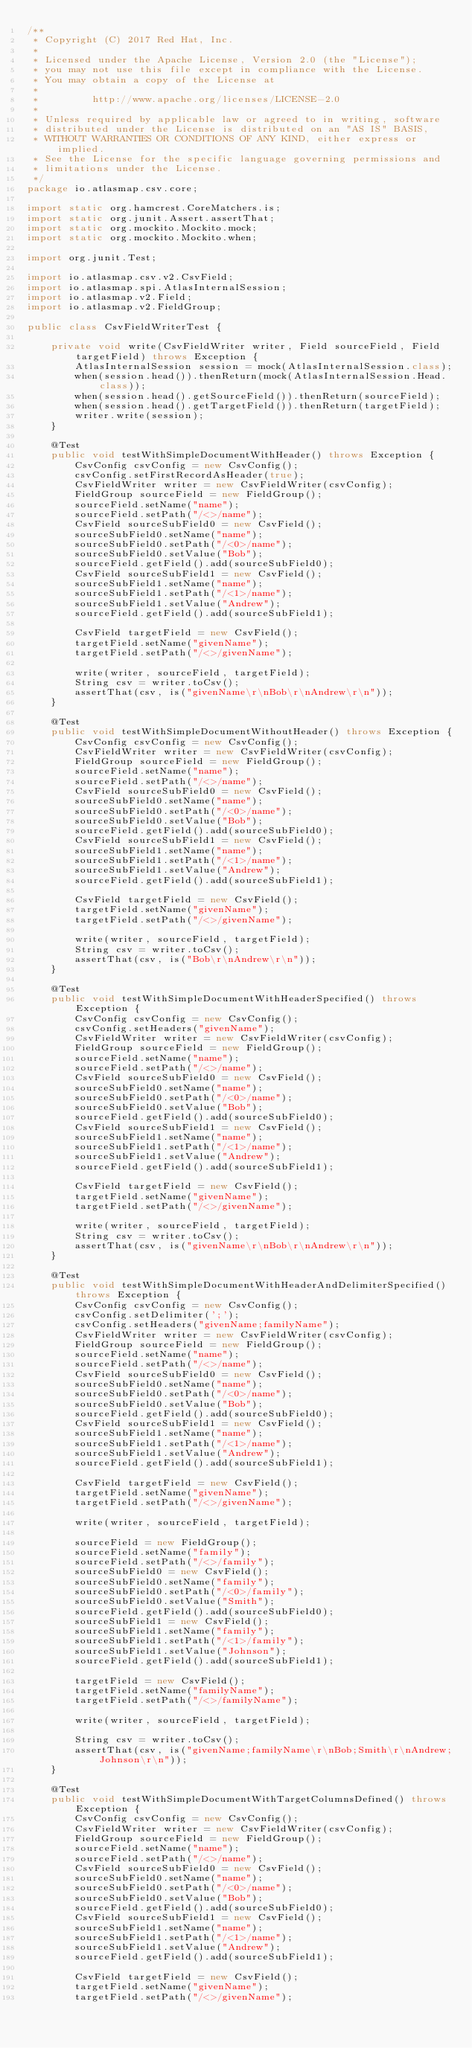Convert code to text. <code><loc_0><loc_0><loc_500><loc_500><_Java_>/**
 * Copyright (C) 2017 Red Hat, Inc.
 *
 * Licensed under the Apache License, Version 2.0 (the "License");
 * you may not use this file except in compliance with the License.
 * You may obtain a copy of the License at
 *
 *         http://www.apache.org/licenses/LICENSE-2.0
 *
 * Unless required by applicable law or agreed to in writing, software
 * distributed under the License is distributed on an "AS IS" BASIS,
 * WITHOUT WARRANTIES OR CONDITIONS OF ANY KIND, either express or implied.
 * See the License for the specific language governing permissions and
 * limitations under the License.
 */
package io.atlasmap.csv.core;

import static org.hamcrest.CoreMatchers.is;
import static org.junit.Assert.assertThat;
import static org.mockito.Mockito.mock;
import static org.mockito.Mockito.when;

import org.junit.Test;

import io.atlasmap.csv.v2.CsvField;
import io.atlasmap.spi.AtlasInternalSession;
import io.atlasmap.v2.Field;
import io.atlasmap.v2.FieldGroup;

public class CsvFieldWriterTest {

    private void write(CsvFieldWriter writer, Field sourceField, Field targetField) throws Exception {
        AtlasInternalSession session = mock(AtlasInternalSession.class);
        when(session.head()).thenReturn(mock(AtlasInternalSession.Head.class));
        when(session.head().getSourceField()).thenReturn(sourceField);
        when(session.head().getTargetField()).thenReturn(targetField);
        writer.write(session);
    }

    @Test
    public void testWithSimpleDocumentWithHeader() throws Exception {
        CsvConfig csvConfig = new CsvConfig();
        csvConfig.setFirstRecordAsHeader(true);
        CsvFieldWriter writer = new CsvFieldWriter(csvConfig);
        FieldGroup sourceField = new FieldGroup();
        sourceField.setName("name");
        sourceField.setPath("/<>/name");
        CsvField sourceSubField0 = new CsvField();
        sourceSubField0.setName("name");
        sourceSubField0.setPath("/<0>/name");
        sourceSubField0.setValue("Bob");
        sourceField.getField().add(sourceSubField0);
        CsvField sourceSubField1 = new CsvField();
        sourceSubField1.setName("name");
        sourceSubField1.setPath("/<1>/name");
        sourceSubField1.setValue("Andrew");
        sourceField.getField().add(sourceSubField1);

        CsvField targetField = new CsvField();
        targetField.setName("givenName");
        targetField.setPath("/<>/givenName");

        write(writer, sourceField, targetField);
        String csv = writer.toCsv();
        assertThat(csv, is("givenName\r\nBob\r\nAndrew\r\n"));
    }

    @Test
    public void testWithSimpleDocumentWithoutHeader() throws Exception {
        CsvConfig csvConfig = new CsvConfig();
        CsvFieldWriter writer = new CsvFieldWriter(csvConfig);
        FieldGroup sourceField = new FieldGroup();
        sourceField.setName("name");
        sourceField.setPath("/<>/name");
        CsvField sourceSubField0 = new CsvField();
        sourceSubField0.setName("name");
        sourceSubField0.setPath("/<0>/name");
        sourceSubField0.setValue("Bob");
        sourceField.getField().add(sourceSubField0);
        CsvField sourceSubField1 = new CsvField();
        sourceSubField1.setName("name");
        sourceSubField1.setPath("/<1>/name");
        sourceSubField1.setValue("Andrew");
        sourceField.getField().add(sourceSubField1);

        CsvField targetField = new CsvField();
        targetField.setName("givenName");
        targetField.setPath("/<>/givenName");

        write(writer, sourceField, targetField);
        String csv = writer.toCsv();
        assertThat(csv, is("Bob\r\nAndrew\r\n"));
    }

    @Test
    public void testWithSimpleDocumentWithHeaderSpecified() throws Exception {
        CsvConfig csvConfig = new CsvConfig();
        csvConfig.setHeaders("givenName");
        CsvFieldWriter writer = new CsvFieldWriter(csvConfig);
        FieldGroup sourceField = new FieldGroup();
        sourceField.setName("name");
        sourceField.setPath("/<>/name");
        CsvField sourceSubField0 = new CsvField();
        sourceSubField0.setName("name");
        sourceSubField0.setPath("/<0>/name");
        sourceSubField0.setValue("Bob");
        sourceField.getField().add(sourceSubField0);
        CsvField sourceSubField1 = new CsvField();
        sourceSubField1.setName("name");
        sourceSubField1.setPath("/<1>/name");
        sourceSubField1.setValue("Andrew");
        sourceField.getField().add(sourceSubField1);

        CsvField targetField = new CsvField();
        targetField.setName("givenName");
        targetField.setPath("/<>/givenName");

        write(writer, sourceField, targetField);
        String csv = writer.toCsv();
        assertThat(csv, is("givenName\r\nBob\r\nAndrew\r\n"));
    }

    @Test
    public void testWithSimpleDocumentWithHeaderAndDelimiterSpecified() throws Exception {
        CsvConfig csvConfig = new CsvConfig();
        csvConfig.setDelimiter(';');
        csvConfig.setHeaders("givenName;familyName");
        CsvFieldWriter writer = new CsvFieldWriter(csvConfig);
        FieldGroup sourceField = new FieldGroup();
        sourceField.setName("name");
        sourceField.setPath("/<>/name");
        CsvField sourceSubField0 = new CsvField();
        sourceSubField0.setName("name");
        sourceSubField0.setPath("/<0>/name");
        sourceSubField0.setValue("Bob");
        sourceField.getField().add(sourceSubField0);
        CsvField sourceSubField1 = new CsvField();
        sourceSubField1.setName("name");
        sourceSubField1.setPath("/<1>/name");
        sourceSubField1.setValue("Andrew");
        sourceField.getField().add(sourceSubField1);

        CsvField targetField = new CsvField();
        targetField.setName("givenName");
        targetField.setPath("/<>/givenName");

        write(writer, sourceField, targetField);

        sourceField = new FieldGroup();
        sourceField.setName("family");
        sourceField.setPath("/<>/family");
        sourceSubField0 = new CsvField();
        sourceSubField0.setName("family");
        sourceSubField0.setPath("/<0>/family");
        sourceSubField0.setValue("Smith");
        sourceField.getField().add(sourceSubField0);
        sourceSubField1 = new CsvField();
        sourceSubField1.setName("family");
        sourceSubField1.setPath("/<1>/family");
        sourceSubField1.setValue("Johnson");
        sourceField.getField().add(sourceSubField1);

        targetField = new CsvField();
        targetField.setName("familyName");
        targetField.setPath("/<>/familyName");

        write(writer, sourceField, targetField);

        String csv = writer.toCsv();
        assertThat(csv, is("givenName;familyName\r\nBob;Smith\r\nAndrew;Johnson\r\n"));
    }

    @Test
    public void testWithSimpleDocumentWithTargetColumnsDefined() throws Exception {
        CsvConfig csvConfig = new CsvConfig();
        CsvFieldWriter writer = new CsvFieldWriter(csvConfig);
        FieldGroup sourceField = new FieldGroup();
        sourceField.setName("name");
        sourceField.setPath("/<>/name");
        CsvField sourceSubField0 = new CsvField();
        sourceSubField0.setName("name");
        sourceSubField0.setPath("/<0>/name");
        sourceSubField0.setValue("Bob");
        sourceField.getField().add(sourceSubField0);
        CsvField sourceSubField1 = new CsvField();
        sourceSubField1.setName("name");
        sourceSubField1.setPath("/<1>/name");
        sourceSubField1.setValue("Andrew");
        sourceField.getField().add(sourceSubField1);

        CsvField targetField = new CsvField();
        targetField.setName("givenName");
        targetField.setPath("/<>/givenName");</code> 